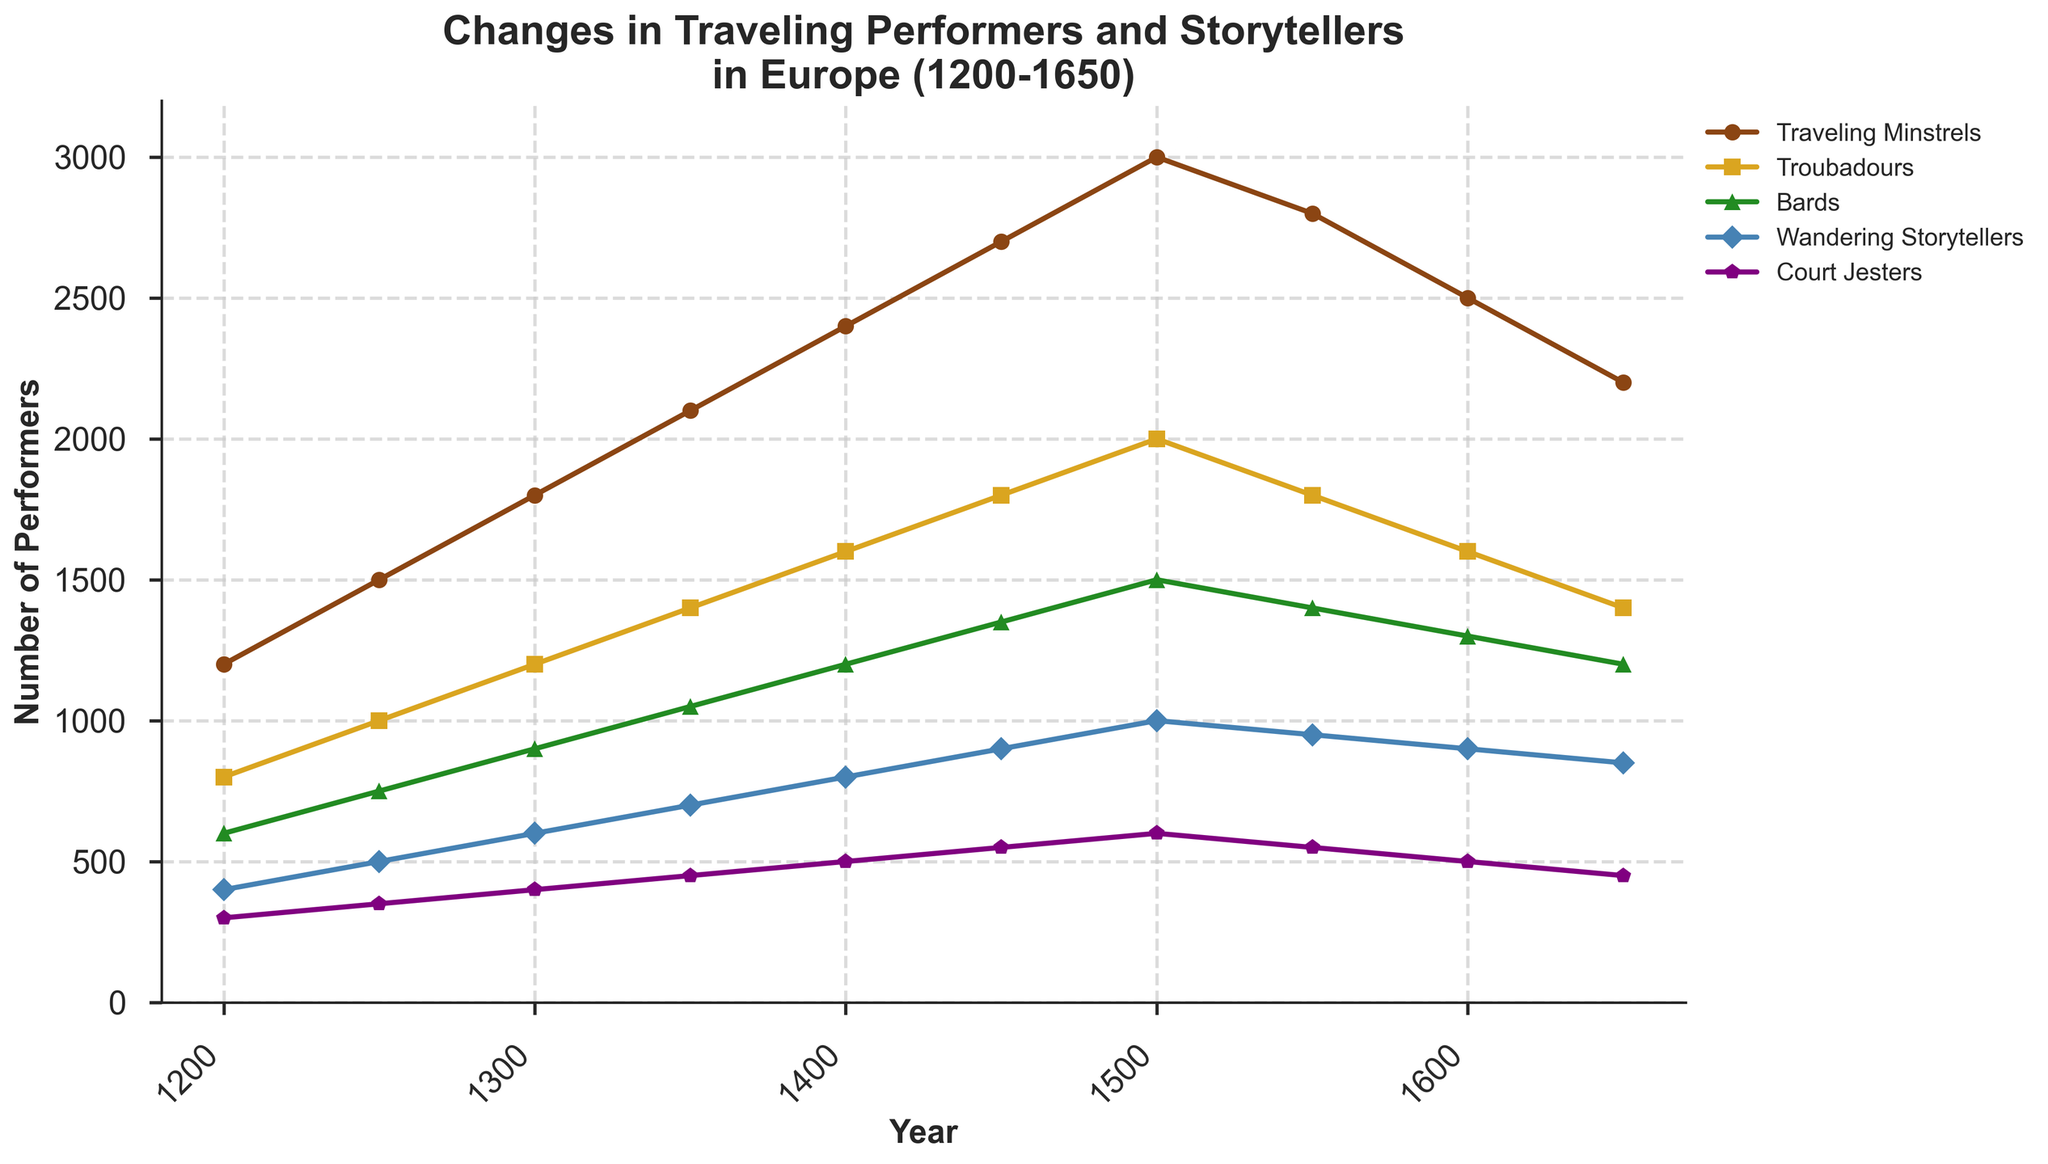What's the general trend for Traveling Minstrels from 1200 to 1650? The plot shows an increasing trend for Traveling Minstrels from 1200, peaking around 1500, and then a gradual decline towards 1650.
Answer: Increasing then decreasing Between which years did Wandering Storytellers experience the most significant growth? By observing the steepest slope in the Wandering Storytellers' line, the period between 1300 to 1450 shows substantial growth.
Answer: 1300 to 1450 How many more Troubadours were there in 1300 compared to Bards in 1250? Checking the number of Troubadours in 1300, it is 1200. The number of Bards in 1250 is 750. The difference is 1200 - 750 = 450.
Answer: 450 Which group experienced a decline from 1550 to 1650, and by how much? Wandering Storytellers dropped from 950 in 1550 to 850 in 1600 and then to 850 in 1650. The total decline from 1550 is 1000 - 850 = 150.
Answer: Wandering Storytellers, 150 In which year did all categories except Court Jesters reach their peak? Observing the peaks for all categories except Court Jesters, they reached their maximum value around the year 1500.
Answer: 1500 How does the number of Court Jesters in 1450 compare to Traveling Minstrels in 1300? The number of Court Jesters in 1450 is 550. The number of Traveling Minstrels in 1300 is 1800. Comparing the two, Traveling Minstrels greatly outnumber Court Jesters.
Answer: Traveling Minstrels > Court Jesters Which performer had the least number in 1200, and what was the count? By observing the data points in the year 1200, Court Jesters had the smallest number, which is 300.
Answer: Court Jesters, 300 What is the difference in the number of Traveling Minstrels between the year 1400 and 1450? The number of Traveling Minstrels in 1400 is 2400, and in 1450, it is 2700. The difference is 2700 - 2400 = 300.
Answer: 300 Which group had the smallest change in numbers from 1250 to 1650? Calculating the difference for each group over this period: Court Jesters change from 350 to 450 (+100), the smallest compared to the other groups' changes.
Answer: Court Jesters What's the average number of Bards between 1200 and 1650? Summing the Bards' numbers over all years is 600 + 750 + 900 + 1050 + 1200 + 1350 + 1500 + 1400 + 1300 + 1200 = 11700. The average is 11700 / 10 = 1170.
Answer: 1170 